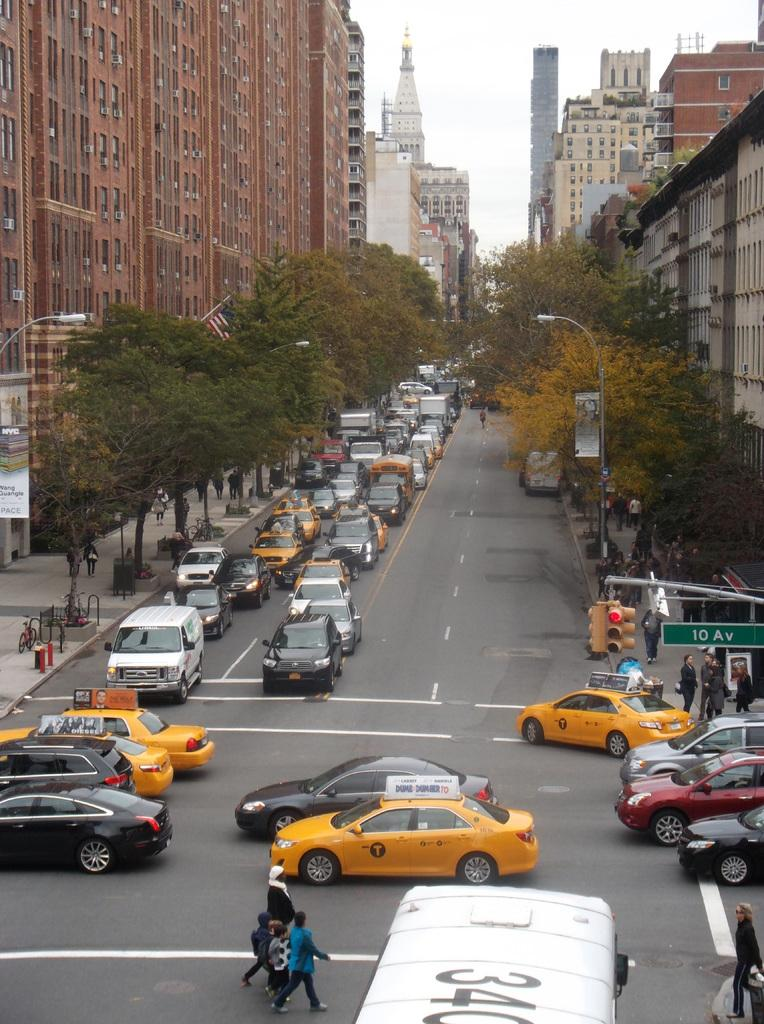Provide a one-sentence caption for the provided image. Cars passing by a busy street on 10 Av. 